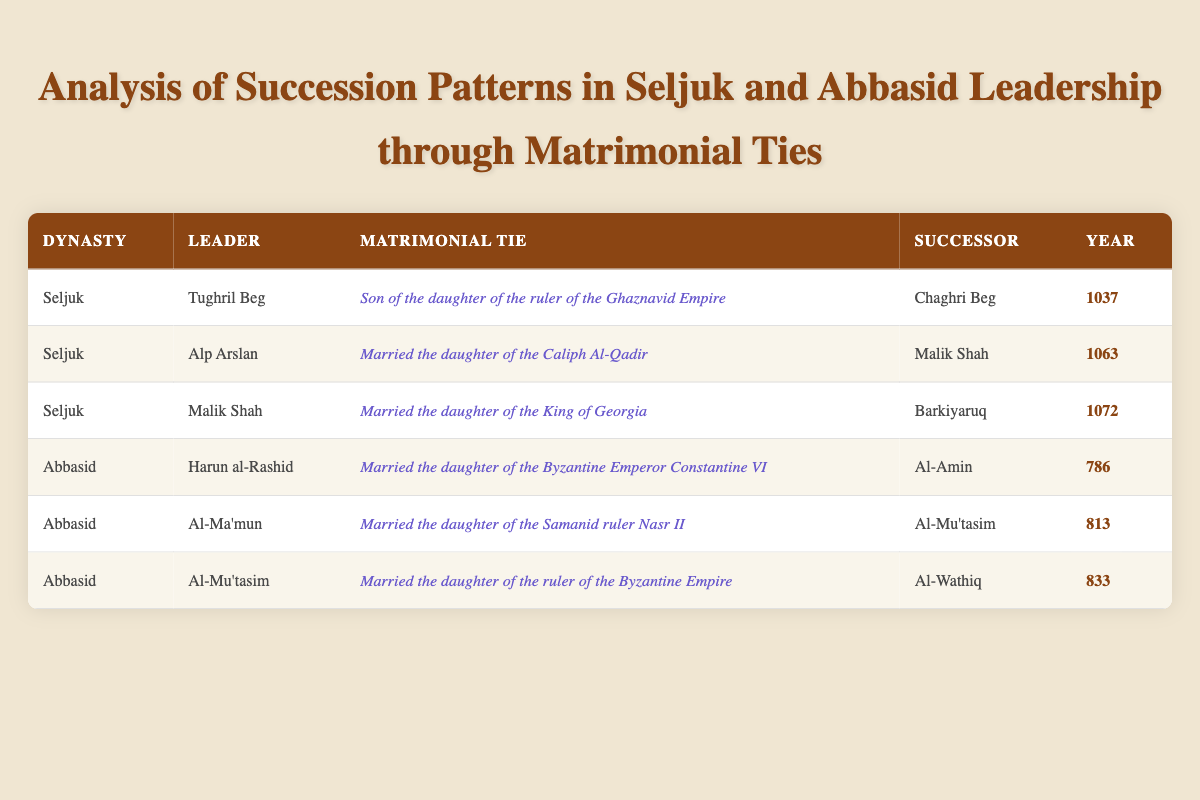What is the matrimonial tie of Tughril Beg? Tughril Beg's matrimonial tie is stated as "Son of the daughter of the ruler of the Ghaznavid Empire" in the table.
Answer: Son of the daughter of the ruler of the Ghaznavid Empire Who succeeded Al-Ma'mun? According to the table, Al-Ma'mun's successor is listed as Al-Mu'tasim.
Answer: Al-Mu'tasim Is it true that all leaders from the Abbasid dynasty listed in the table married into Byzantine royalty? The table shows that Harun al-Rashid married the daughter of the Byzantine Emperor, and Al-Mu'tasim married the daughter of the ruler of the Byzantine Empire, confirming their marriages into Byzantine royalty. However, Al-Ma'mun married the daughter of the Samanid ruler, which does not involve Byzantine royalty. Therefore, the statement is false.
Answer: No How many leaders had successors who came into power after the year 800? Analyzing the table, the leaders who have successors after the year 800 are Al-Ma'mun (813) and Al-Mu'tasim (833). Therefore, there are 2 such leaders.
Answer: 2 Which dynasty had more leaders listed in the table? The table shows three leaders from the Seljuk dynasty (Tughril Beg, Alp Arslan, Malik Shah) and three from the Abbasid dynasty (Harun al-Rashid, Al-Ma'mun, and Al-Mu'tasim). Since both dynasties have an equal number of leaders, the answer is that neither has more leaders than the other.
Answer: Neither What is the earliest year of succession mentioned in the table? The table shows Tughril Beg as the leader with succession in the year 1037 and Harun al-Rashid in the year 786. The earliest year of succession is therefore 786.
Answer: 786 What was the matrimonial tie of Malik Shah? In the table, Malik Shah's matrimonial tie is described as "Married the daughter of the King of Georgia."
Answer: Married the daughter of the King of Georgia What is the difference in years between the succession of Tughril Beg and Malik Shah? The years of succession for Tughril Beg and Malik Shah are 1037 and 1072, respectively. The difference in years is calculated as 1072 - 1037 = 35 years.
Answer: 35 